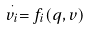Convert formula to latex. <formula><loc_0><loc_0><loc_500><loc_500>\stackrel { \cdot } { v _ { i } } = f _ { i } ( q , v )</formula> 